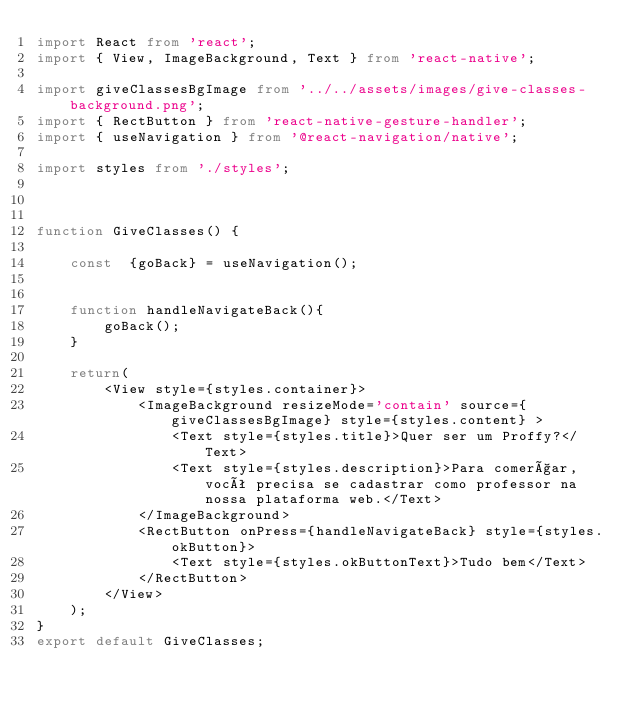<code> <loc_0><loc_0><loc_500><loc_500><_TypeScript_>import React from 'react';
import { View, ImageBackground, Text } from 'react-native';

import giveClassesBgImage from '../../assets/images/give-classes-background.png';
import { RectButton } from 'react-native-gesture-handler';
import { useNavigation } from '@react-navigation/native';

import styles from './styles';



function GiveClasses() {

    const  {goBack} = useNavigation();


    function handleNavigateBack(){
        goBack();
    }

    return( 
        <View style={styles.container}>
            <ImageBackground resizeMode='contain' source={giveClassesBgImage} style={styles.content} >
                <Text style={styles.title}>Quer ser um Proffy?</Text>
                <Text style={styles.description}>Para comerçar, você precisa se cadastrar como professor na nossa plataforma web.</Text>
            </ImageBackground>
            <RectButton onPress={handleNavigateBack} style={styles.okButton}>
                <Text style={styles.okButtonText}>Tudo bem</Text>
            </RectButton>
        </View>
    );
}
export default GiveClasses;</code> 